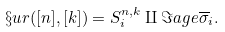<formula> <loc_0><loc_0><loc_500><loc_500>\S u r ( [ n ] , [ k ] ) = S ^ { n , k } _ { i } \amalg \Im a g e \overline { \sigma } _ { i } .</formula> 